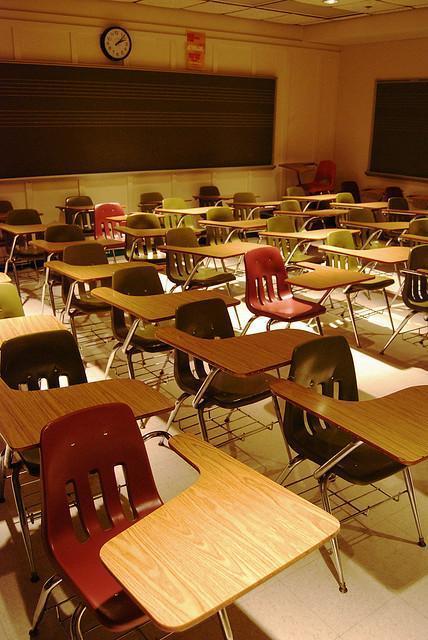How many left handed desks are clearly visible?
Give a very brief answer. 2. How many chairs are there?
Give a very brief answer. 8. How many airplane lights are red?
Give a very brief answer. 0. 